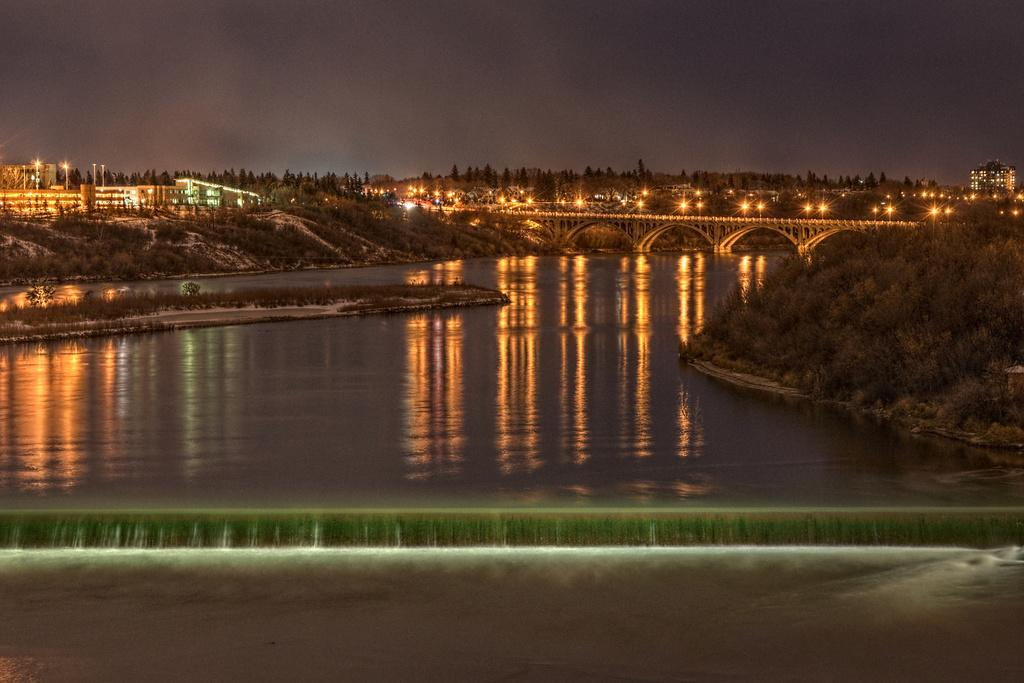What type of structures can be seen in the image? There are buildings in the image. What else can be seen in the image besides buildings? There are trees, light poles on a bridge, and plants in the image. What is visible at the top of the image? The sky is visible at the top of the image. What is visible at the bottom of the image? There is water visible at the bottom of the image. What month is it in the image? The month cannot be determined from the image, as it does not contain any information about the time of year. Is there a bomb present in the image? No, there is no bomb present in the image. 